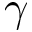<formula> <loc_0><loc_0><loc_500><loc_500>\gamma</formula> 